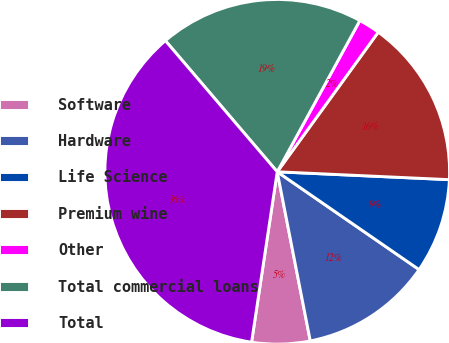Convert chart to OTSL. <chart><loc_0><loc_0><loc_500><loc_500><pie_chart><fcel>Software<fcel>Hardware<fcel>Life Science<fcel>Premium wine<fcel>Other<fcel>Total commercial loans<fcel>Total<nl><fcel>5.45%<fcel>12.32%<fcel>8.88%<fcel>15.76%<fcel>2.01%<fcel>19.2%<fcel>36.38%<nl></chart> 